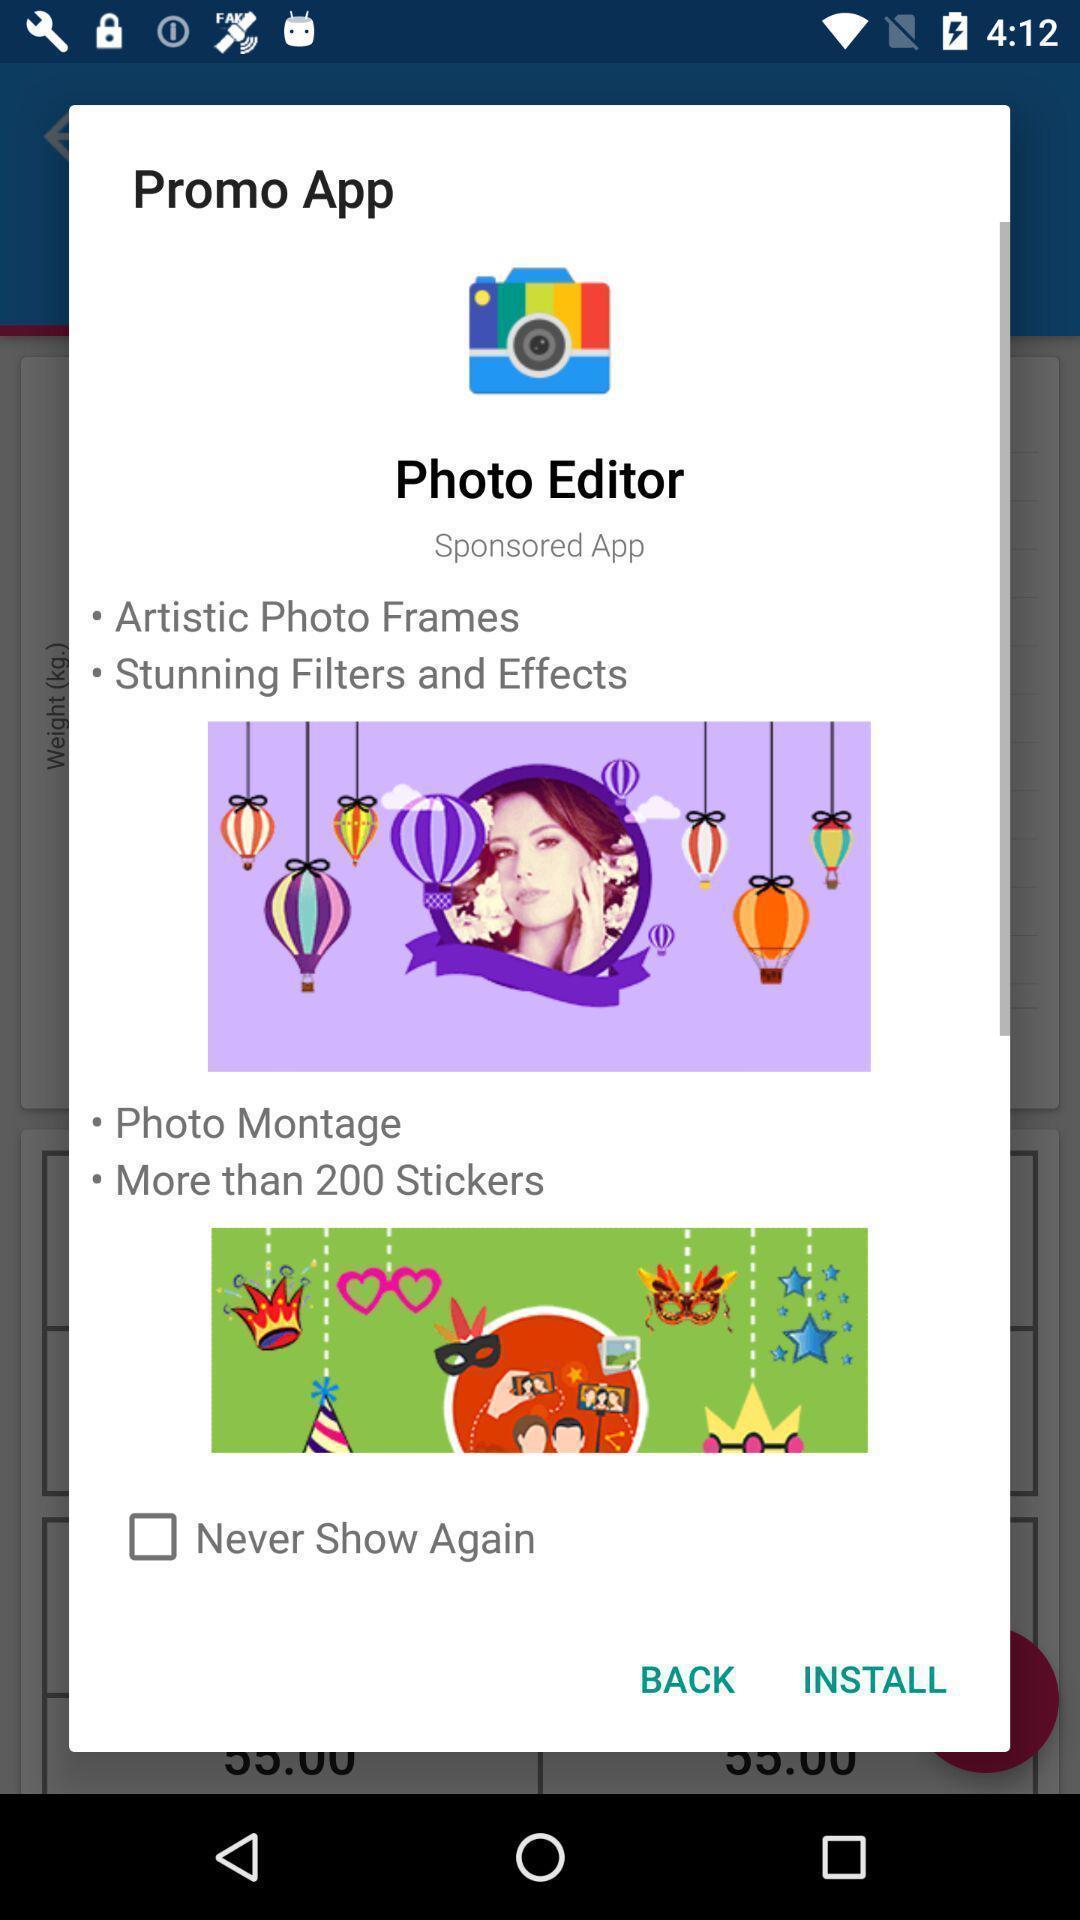Explain the elements present in this screenshot. Pop-up displaying with the application recommendation to install. 